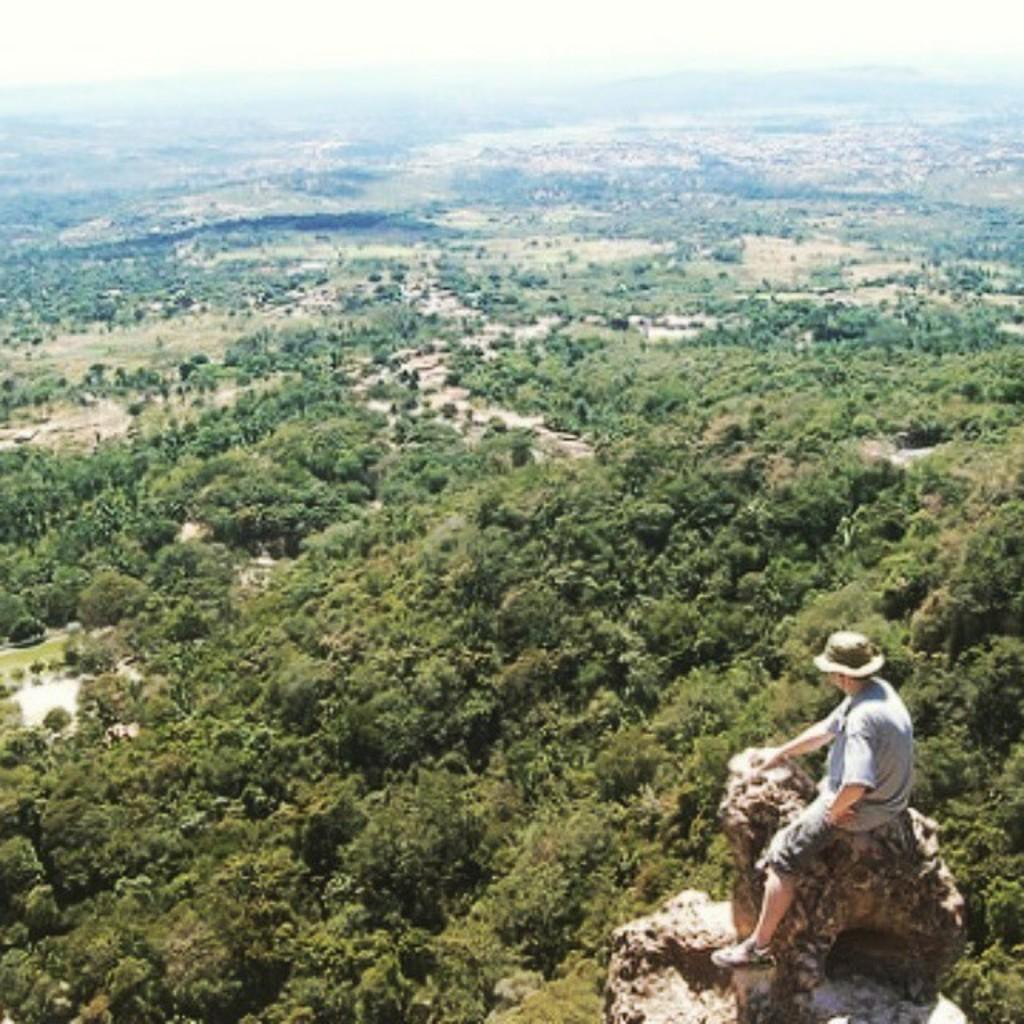What is the person in the image doing? The person is sitting on a rock in the image. What can be seen in the background of the image? There is greenery visible from left to right in the image. What type of sleet is falling on the person in the image? There is no sleet present in the image; the weather appears to be clear with greenery visible. Can you tell me how many tomatoes are on the rock with the person? There are no tomatoes present in the image; the person is sitting on a rock with no visible objects other than themselves. 